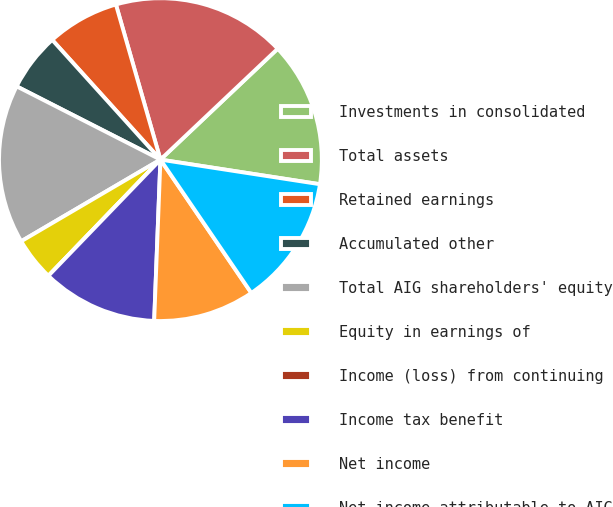<chart> <loc_0><loc_0><loc_500><loc_500><pie_chart><fcel>Investments in consolidated<fcel>Total assets<fcel>Retained earnings<fcel>Accumulated other<fcel>Total AIG shareholders' equity<fcel>Equity in earnings of<fcel>Income (loss) from continuing<fcel>Income tax benefit<fcel>Net income<fcel>Net income attributable to AIG<nl><fcel>14.49%<fcel>17.39%<fcel>7.25%<fcel>5.8%<fcel>15.94%<fcel>4.35%<fcel>0.0%<fcel>11.59%<fcel>10.14%<fcel>13.04%<nl></chart> 